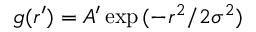Convert formula to latex. <formula><loc_0><loc_0><loc_500><loc_500>g ( r ^ { \prime } ) = A ^ { \prime } \exp { ( - r ^ { 2 } / 2 \sigma ^ { 2 } ) }</formula> 